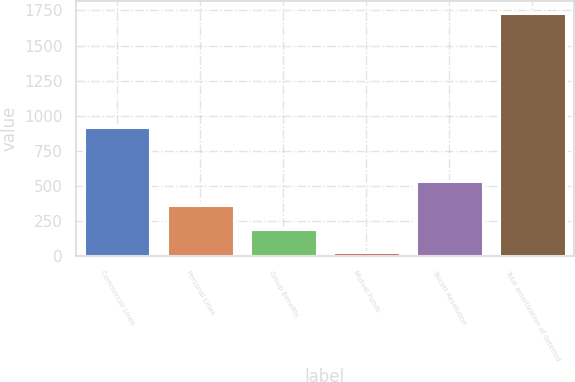Convert chart to OTSL. <chart><loc_0><loc_0><loc_500><loc_500><bar_chart><fcel>Commercial Lines<fcel>Personal Lines<fcel>Group Benefits<fcel>Mutual Funds<fcel>Talcott Resolution<fcel>Total amortization of deferred<nl><fcel>919<fcel>368.2<fcel>198.1<fcel>28<fcel>538.3<fcel>1729<nl></chart> 